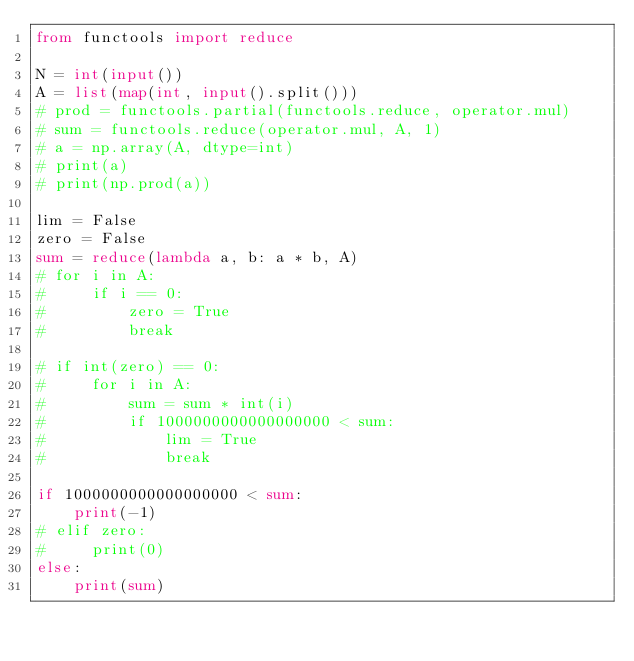<code> <loc_0><loc_0><loc_500><loc_500><_Python_>from functools import reduce

N = int(input())
A = list(map(int, input().split()))
# prod = functools.partial(functools.reduce, operator.mul)
# sum = functools.reduce(operator.mul, A, 1)
# a = np.array(A, dtype=int)
# print(a)
# print(np.prod(a))

lim = False
zero = False
sum = reduce(lambda a, b: a * b, A)
# for i in A:
#     if i == 0:
#         zero = True
#         break

# if int(zero) == 0:
#     for i in A:
#         sum = sum * int(i)
#         if 1000000000000000000 < sum:
#             lim = True
#             break

if 1000000000000000000 < sum:
    print(-1)
# elif zero:
#     print(0)
else:
    print(sum)
</code> 